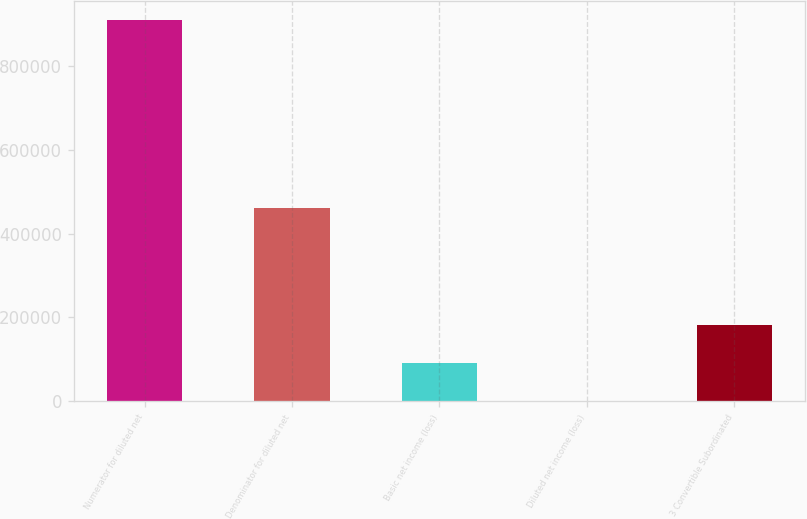Convert chart to OTSL. <chart><loc_0><loc_0><loc_500><loc_500><bar_chart><fcel>Numerator for diluted net<fcel>Denominator for diluted net<fcel>Basic net income (loss)<fcel>Diluted net income (loss)<fcel>3 Convertible Subordinated<nl><fcel>909585<fcel>460226<fcel>90960.3<fcel>1.98<fcel>181919<nl></chart> 